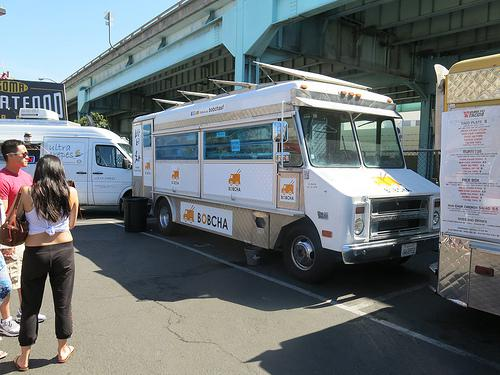Question: when was the picture taken?
Choices:
A. Morning.
B. Noon.
C. During the day.
D. Dusk.
Answer with the letter. Answer: C Question: where are the people standing?
Choices:
A. In the house.
B. By the road.
C. In the school.
D. By the food trucks.
Answer with the letter. Answer: D Question: who is standing in the picture?
Choices:
A. A man.
B. People.
C. A woman.
D. A boy.
Answer with the letter. Answer: B Question: what color is the sky?
Choices:
A. Grey.
B. Blue.
C. White.
D. Pink.
Answer with the letter. Answer: B Question: what color pants is the women wearing?
Choices:
A. Black.
B. Red.
C. Blue.
D. Tan.
Answer with the letter. Answer: A Question: how people can be seen in the picture?
Choices:
A. Four.
B. Seven.
C. Two.
D. Three.
Answer with the letter. Answer: C Question: what color shirt is the man wearing?
Choices:
A. Black.
B. Green.
C. Orange.
D. Red.
Answer with the letter. Answer: D 